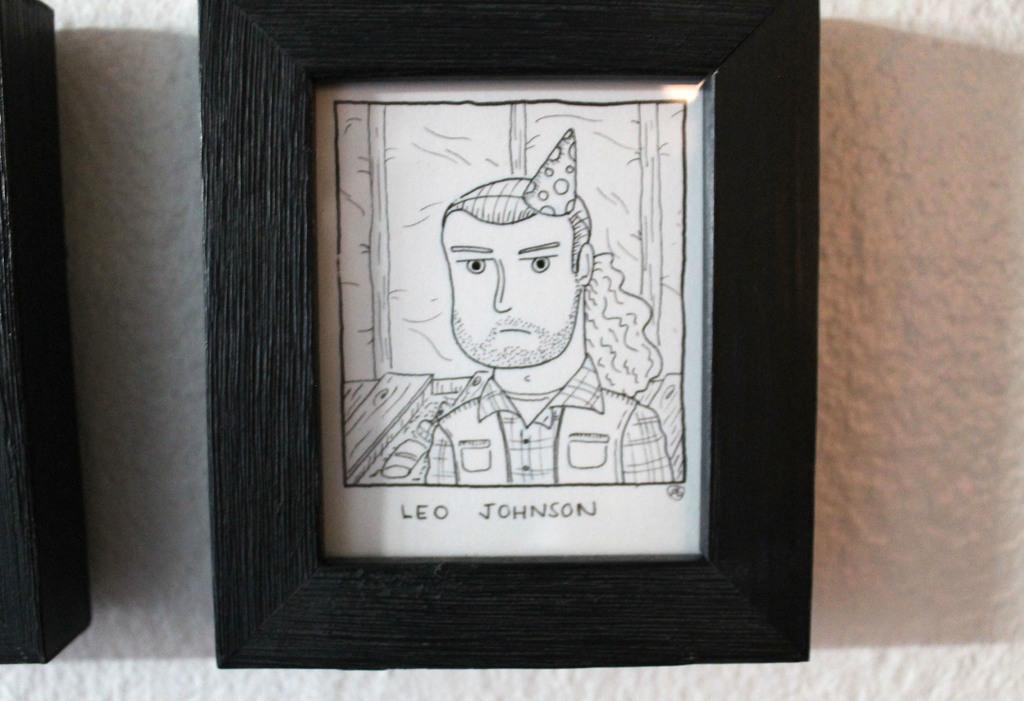Please provide a concise description of this image. In this image we can see the frame with sketch and some text below the sketch attached to the wall. There is one white wall in the background, one frame truncated on the left side of the image and we can see the reflection of light in the frame. 